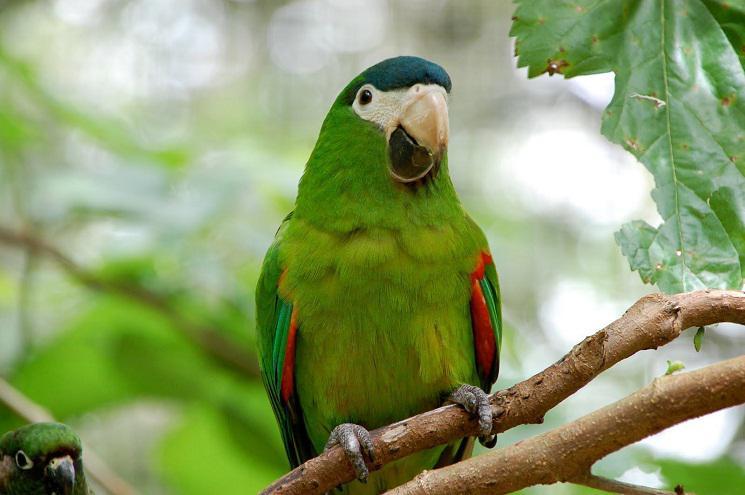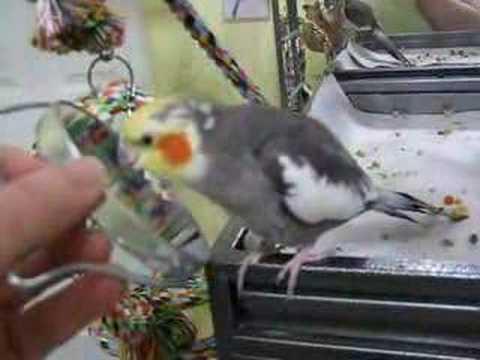The first image is the image on the left, the second image is the image on the right. Given the left and right images, does the statement "An image contains one right-facing parrot in front of a mesh." hold true? Answer yes or no. No. The first image is the image on the left, the second image is the image on the right. Assess this claim about the two images: "There are two parrots in total, both with predominantly green feathers.". Correct or not? Answer yes or no. No. 